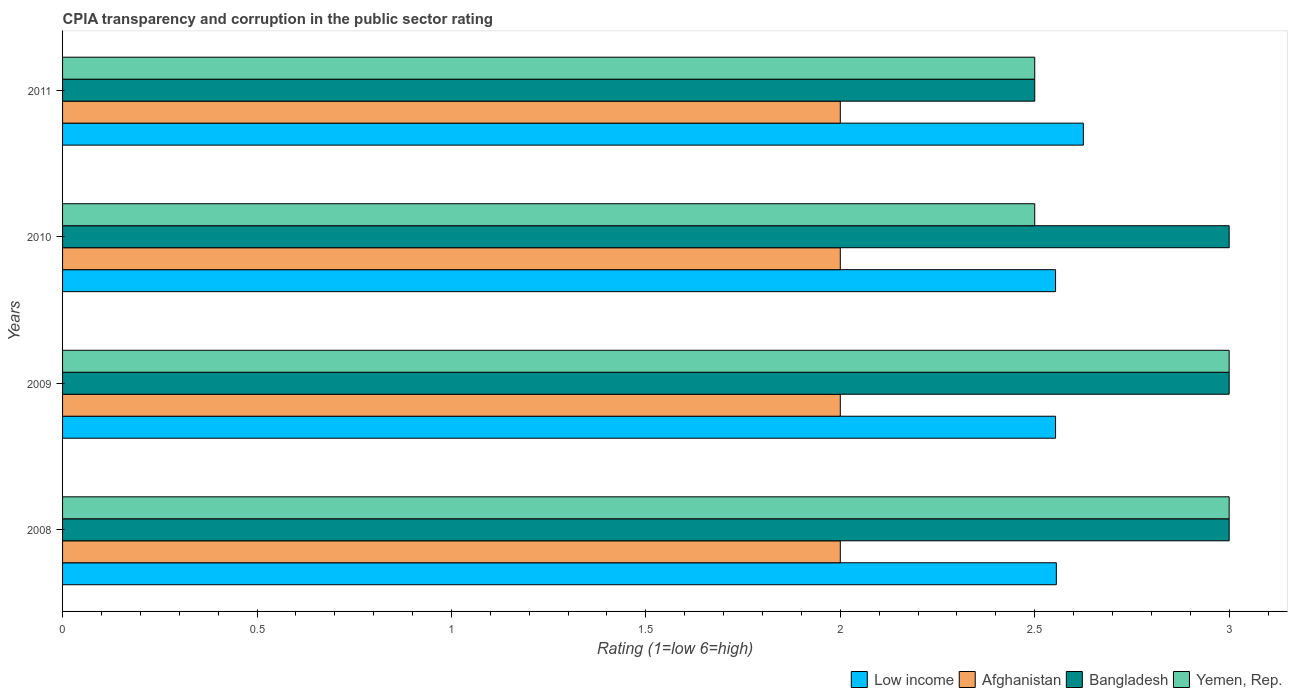Are the number of bars on each tick of the Y-axis equal?
Offer a very short reply. Yes. How many bars are there on the 3rd tick from the bottom?
Your answer should be compact. 4. In how many cases, is the number of bars for a given year not equal to the number of legend labels?
Offer a very short reply. 0. What is the CPIA rating in Low income in 2008?
Offer a very short reply. 2.56. Across all years, what is the maximum CPIA rating in Low income?
Offer a terse response. 2.62. Across all years, what is the minimum CPIA rating in Bangladesh?
Provide a succinct answer. 2.5. What is the total CPIA rating in Bangladesh in the graph?
Your answer should be compact. 11.5. What is the difference between the CPIA rating in Afghanistan in 2009 and the CPIA rating in Yemen, Rep. in 2008?
Offer a very short reply. -1. What is the average CPIA rating in Bangladesh per year?
Your answer should be compact. 2.88. What is the ratio of the CPIA rating in Afghanistan in 2008 to that in 2011?
Your response must be concise. 1. Is the difference between the CPIA rating in Yemen, Rep. in 2008 and 2009 greater than the difference between the CPIA rating in Bangladesh in 2008 and 2009?
Offer a very short reply. No. What is the difference between the highest and the second highest CPIA rating in Low income?
Keep it short and to the point. 0.07. What is the difference between the highest and the lowest CPIA rating in Low income?
Offer a terse response. 0.07. In how many years, is the CPIA rating in Afghanistan greater than the average CPIA rating in Afghanistan taken over all years?
Give a very brief answer. 0. What does the 2nd bar from the top in 2010 represents?
Make the answer very short. Bangladesh. Are the values on the major ticks of X-axis written in scientific E-notation?
Make the answer very short. No. Does the graph contain any zero values?
Keep it short and to the point. No. Where does the legend appear in the graph?
Provide a succinct answer. Bottom right. How many legend labels are there?
Give a very brief answer. 4. What is the title of the graph?
Offer a very short reply. CPIA transparency and corruption in the public sector rating. What is the label or title of the X-axis?
Make the answer very short. Rating (1=low 6=high). What is the Rating (1=low 6=high) of Low income in 2008?
Provide a succinct answer. 2.56. What is the Rating (1=low 6=high) in Afghanistan in 2008?
Give a very brief answer. 2. What is the Rating (1=low 6=high) in Yemen, Rep. in 2008?
Provide a short and direct response. 3. What is the Rating (1=low 6=high) of Low income in 2009?
Provide a succinct answer. 2.55. What is the Rating (1=low 6=high) of Afghanistan in 2009?
Keep it short and to the point. 2. What is the Rating (1=low 6=high) in Yemen, Rep. in 2009?
Provide a short and direct response. 3. What is the Rating (1=low 6=high) in Low income in 2010?
Offer a terse response. 2.55. What is the Rating (1=low 6=high) in Afghanistan in 2010?
Provide a short and direct response. 2. What is the Rating (1=low 6=high) in Yemen, Rep. in 2010?
Offer a terse response. 2.5. What is the Rating (1=low 6=high) in Low income in 2011?
Your answer should be very brief. 2.62. What is the Rating (1=low 6=high) of Afghanistan in 2011?
Provide a short and direct response. 2. What is the Rating (1=low 6=high) of Yemen, Rep. in 2011?
Your answer should be compact. 2.5. Across all years, what is the maximum Rating (1=low 6=high) in Low income?
Your answer should be compact. 2.62. Across all years, what is the maximum Rating (1=low 6=high) of Afghanistan?
Offer a very short reply. 2. Across all years, what is the minimum Rating (1=low 6=high) of Low income?
Your response must be concise. 2.55. Across all years, what is the minimum Rating (1=low 6=high) of Afghanistan?
Provide a succinct answer. 2. Across all years, what is the minimum Rating (1=low 6=high) of Bangladesh?
Your response must be concise. 2.5. Across all years, what is the minimum Rating (1=low 6=high) of Yemen, Rep.?
Provide a succinct answer. 2.5. What is the total Rating (1=low 6=high) in Low income in the graph?
Offer a terse response. 10.29. What is the total Rating (1=low 6=high) in Afghanistan in the graph?
Ensure brevity in your answer.  8. What is the difference between the Rating (1=low 6=high) in Low income in 2008 and that in 2009?
Ensure brevity in your answer.  0. What is the difference between the Rating (1=low 6=high) in Afghanistan in 2008 and that in 2009?
Make the answer very short. 0. What is the difference between the Rating (1=low 6=high) in Low income in 2008 and that in 2010?
Offer a very short reply. 0. What is the difference between the Rating (1=low 6=high) of Low income in 2008 and that in 2011?
Offer a very short reply. -0.07. What is the difference between the Rating (1=low 6=high) in Afghanistan in 2008 and that in 2011?
Provide a short and direct response. 0. What is the difference between the Rating (1=low 6=high) of Bangladesh in 2008 and that in 2011?
Offer a very short reply. 0.5. What is the difference between the Rating (1=low 6=high) of Afghanistan in 2009 and that in 2010?
Keep it short and to the point. 0. What is the difference between the Rating (1=low 6=high) in Bangladesh in 2009 and that in 2010?
Give a very brief answer. 0. What is the difference between the Rating (1=low 6=high) in Yemen, Rep. in 2009 and that in 2010?
Your response must be concise. 0.5. What is the difference between the Rating (1=low 6=high) in Low income in 2009 and that in 2011?
Your response must be concise. -0.07. What is the difference between the Rating (1=low 6=high) in Afghanistan in 2009 and that in 2011?
Keep it short and to the point. 0. What is the difference between the Rating (1=low 6=high) of Bangladesh in 2009 and that in 2011?
Offer a terse response. 0.5. What is the difference between the Rating (1=low 6=high) in Yemen, Rep. in 2009 and that in 2011?
Offer a terse response. 0.5. What is the difference between the Rating (1=low 6=high) in Low income in 2010 and that in 2011?
Give a very brief answer. -0.07. What is the difference between the Rating (1=low 6=high) of Bangladesh in 2010 and that in 2011?
Your answer should be compact. 0.5. What is the difference between the Rating (1=low 6=high) of Low income in 2008 and the Rating (1=low 6=high) of Afghanistan in 2009?
Offer a very short reply. 0.56. What is the difference between the Rating (1=low 6=high) of Low income in 2008 and the Rating (1=low 6=high) of Bangladesh in 2009?
Provide a short and direct response. -0.44. What is the difference between the Rating (1=low 6=high) in Low income in 2008 and the Rating (1=low 6=high) in Yemen, Rep. in 2009?
Provide a succinct answer. -0.44. What is the difference between the Rating (1=low 6=high) in Afghanistan in 2008 and the Rating (1=low 6=high) in Bangladesh in 2009?
Offer a terse response. -1. What is the difference between the Rating (1=low 6=high) in Low income in 2008 and the Rating (1=low 6=high) in Afghanistan in 2010?
Your response must be concise. 0.56. What is the difference between the Rating (1=low 6=high) in Low income in 2008 and the Rating (1=low 6=high) in Bangladesh in 2010?
Make the answer very short. -0.44. What is the difference between the Rating (1=low 6=high) of Low income in 2008 and the Rating (1=low 6=high) of Yemen, Rep. in 2010?
Keep it short and to the point. 0.06. What is the difference between the Rating (1=low 6=high) in Afghanistan in 2008 and the Rating (1=low 6=high) in Bangladesh in 2010?
Your response must be concise. -1. What is the difference between the Rating (1=low 6=high) of Low income in 2008 and the Rating (1=low 6=high) of Afghanistan in 2011?
Provide a short and direct response. 0.56. What is the difference between the Rating (1=low 6=high) of Low income in 2008 and the Rating (1=low 6=high) of Bangladesh in 2011?
Ensure brevity in your answer.  0.06. What is the difference between the Rating (1=low 6=high) of Low income in 2008 and the Rating (1=low 6=high) of Yemen, Rep. in 2011?
Provide a short and direct response. 0.06. What is the difference between the Rating (1=low 6=high) of Afghanistan in 2008 and the Rating (1=low 6=high) of Bangladesh in 2011?
Offer a very short reply. -0.5. What is the difference between the Rating (1=low 6=high) of Low income in 2009 and the Rating (1=low 6=high) of Afghanistan in 2010?
Give a very brief answer. 0.55. What is the difference between the Rating (1=low 6=high) of Low income in 2009 and the Rating (1=low 6=high) of Bangladesh in 2010?
Your response must be concise. -0.45. What is the difference between the Rating (1=low 6=high) in Low income in 2009 and the Rating (1=low 6=high) in Yemen, Rep. in 2010?
Offer a terse response. 0.05. What is the difference between the Rating (1=low 6=high) of Bangladesh in 2009 and the Rating (1=low 6=high) of Yemen, Rep. in 2010?
Your answer should be very brief. 0.5. What is the difference between the Rating (1=low 6=high) in Low income in 2009 and the Rating (1=low 6=high) in Afghanistan in 2011?
Your response must be concise. 0.55. What is the difference between the Rating (1=low 6=high) of Low income in 2009 and the Rating (1=low 6=high) of Bangladesh in 2011?
Provide a short and direct response. 0.05. What is the difference between the Rating (1=low 6=high) in Low income in 2009 and the Rating (1=low 6=high) in Yemen, Rep. in 2011?
Offer a very short reply. 0.05. What is the difference between the Rating (1=low 6=high) of Afghanistan in 2009 and the Rating (1=low 6=high) of Bangladesh in 2011?
Your answer should be compact. -0.5. What is the difference between the Rating (1=low 6=high) in Low income in 2010 and the Rating (1=low 6=high) in Afghanistan in 2011?
Provide a short and direct response. 0.55. What is the difference between the Rating (1=low 6=high) in Low income in 2010 and the Rating (1=low 6=high) in Bangladesh in 2011?
Ensure brevity in your answer.  0.05. What is the difference between the Rating (1=low 6=high) in Low income in 2010 and the Rating (1=low 6=high) in Yemen, Rep. in 2011?
Ensure brevity in your answer.  0.05. What is the difference between the Rating (1=low 6=high) in Afghanistan in 2010 and the Rating (1=low 6=high) in Bangladesh in 2011?
Provide a short and direct response. -0.5. What is the difference between the Rating (1=low 6=high) in Afghanistan in 2010 and the Rating (1=low 6=high) in Yemen, Rep. in 2011?
Keep it short and to the point. -0.5. What is the average Rating (1=low 6=high) of Low income per year?
Provide a short and direct response. 2.57. What is the average Rating (1=low 6=high) of Afghanistan per year?
Offer a very short reply. 2. What is the average Rating (1=low 6=high) of Bangladesh per year?
Your answer should be very brief. 2.88. What is the average Rating (1=low 6=high) in Yemen, Rep. per year?
Provide a short and direct response. 2.75. In the year 2008, what is the difference between the Rating (1=low 6=high) of Low income and Rating (1=low 6=high) of Afghanistan?
Provide a short and direct response. 0.56. In the year 2008, what is the difference between the Rating (1=low 6=high) in Low income and Rating (1=low 6=high) in Bangladesh?
Keep it short and to the point. -0.44. In the year 2008, what is the difference between the Rating (1=low 6=high) in Low income and Rating (1=low 6=high) in Yemen, Rep.?
Your response must be concise. -0.44. In the year 2008, what is the difference between the Rating (1=low 6=high) in Afghanistan and Rating (1=low 6=high) in Bangladesh?
Your response must be concise. -1. In the year 2008, what is the difference between the Rating (1=low 6=high) in Afghanistan and Rating (1=low 6=high) in Yemen, Rep.?
Make the answer very short. -1. In the year 2008, what is the difference between the Rating (1=low 6=high) in Bangladesh and Rating (1=low 6=high) in Yemen, Rep.?
Ensure brevity in your answer.  0. In the year 2009, what is the difference between the Rating (1=low 6=high) in Low income and Rating (1=low 6=high) in Afghanistan?
Provide a short and direct response. 0.55. In the year 2009, what is the difference between the Rating (1=low 6=high) in Low income and Rating (1=low 6=high) in Bangladesh?
Your answer should be compact. -0.45. In the year 2009, what is the difference between the Rating (1=low 6=high) in Low income and Rating (1=low 6=high) in Yemen, Rep.?
Offer a very short reply. -0.45. In the year 2009, what is the difference between the Rating (1=low 6=high) in Afghanistan and Rating (1=low 6=high) in Bangladesh?
Offer a very short reply. -1. In the year 2009, what is the difference between the Rating (1=low 6=high) of Afghanistan and Rating (1=low 6=high) of Yemen, Rep.?
Your response must be concise. -1. In the year 2010, what is the difference between the Rating (1=low 6=high) of Low income and Rating (1=low 6=high) of Afghanistan?
Your answer should be compact. 0.55. In the year 2010, what is the difference between the Rating (1=low 6=high) in Low income and Rating (1=low 6=high) in Bangladesh?
Provide a succinct answer. -0.45. In the year 2010, what is the difference between the Rating (1=low 6=high) in Low income and Rating (1=low 6=high) in Yemen, Rep.?
Keep it short and to the point. 0.05. In the year 2010, what is the difference between the Rating (1=low 6=high) of Afghanistan and Rating (1=low 6=high) of Bangladesh?
Your response must be concise. -1. In the year 2010, what is the difference between the Rating (1=low 6=high) in Afghanistan and Rating (1=low 6=high) in Yemen, Rep.?
Make the answer very short. -0.5. In the year 2010, what is the difference between the Rating (1=low 6=high) of Bangladesh and Rating (1=low 6=high) of Yemen, Rep.?
Provide a short and direct response. 0.5. In the year 2011, what is the difference between the Rating (1=low 6=high) in Low income and Rating (1=low 6=high) in Afghanistan?
Give a very brief answer. 0.62. In the year 2011, what is the difference between the Rating (1=low 6=high) of Low income and Rating (1=low 6=high) of Bangladesh?
Offer a terse response. 0.12. In the year 2011, what is the difference between the Rating (1=low 6=high) of Afghanistan and Rating (1=low 6=high) of Yemen, Rep.?
Offer a very short reply. -0.5. In the year 2011, what is the difference between the Rating (1=low 6=high) in Bangladesh and Rating (1=low 6=high) in Yemen, Rep.?
Your response must be concise. 0. What is the ratio of the Rating (1=low 6=high) of Low income in 2008 to that in 2010?
Your response must be concise. 1. What is the ratio of the Rating (1=low 6=high) of Low income in 2008 to that in 2011?
Offer a terse response. 0.97. What is the ratio of the Rating (1=low 6=high) in Bangladesh in 2008 to that in 2011?
Give a very brief answer. 1.2. What is the ratio of the Rating (1=low 6=high) of Yemen, Rep. in 2008 to that in 2011?
Your answer should be very brief. 1.2. What is the ratio of the Rating (1=low 6=high) in Yemen, Rep. in 2009 to that in 2010?
Your answer should be compact. 1.2. What is the ratio of the Rating (1=low 6=high) in Low income in 2009 to that in 2011?
Offer a terse response. 0.97. What is the ratio of the Rating (1=low 6=high) of Yemen, Rep. in 2009 to that in 2011?
Give a very brief answer. 1.2. What is the ratio of the Rating (1=low 6=high) in Low income in 2010 to that in 2011?
Offer a terse response. 0.97. What is the ratio of the Rating (1=low 6=high) in Bangladesh in 2010 to that in 2011?
Keep it short and to the point. 1.2. What is the difference between the highest and the second highest Rating (1=low 6=high) in Low income?
Your answer should be very brief. 0.07. What is the difference between the highest and the lowest Rating (1=low 6=high) of Low income?
Offer a very short reply. 0.07. What is the difference between the highest and the lowest Rating (1=low 6=high) of Bangladesh?
Provide a succinct answer. 0.5. What is the difference between the highest and the lowest Rating (1=low 6=high) of Yemen, Rep.?
Ensure brevity in your answer.  0.5. 